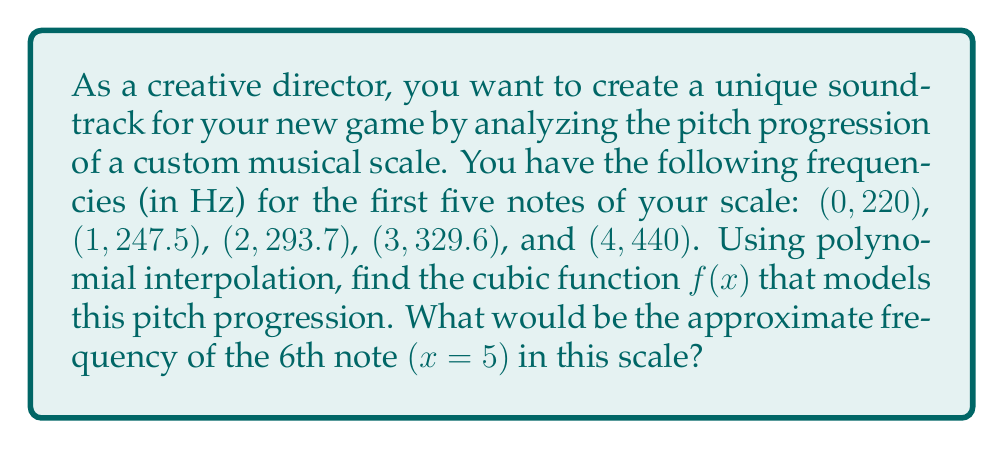What is the answer to this math problem? To solve this problem, we'll use Lagrange polynomial interpolation to find the cubic function that fits the given data points. Then, we'll use this function to estimate the frequency of the 6th note.

Step 1: Set up the Lagrange polynomial formula for a cubic function:

$$f(x) = y_0L_0(x) + y_1L_1(x) + y_2L_2(x) + y_3L_3(x) + y_4L_4(x)$$

Where $L_i(x)$ are the Lagrange basis polynomials:

$$L_i(x) = \prod_{j \neq i} \frac{x - x_j}{x_i - x_j}$$

Step 2: Calculate each Lagrange basis polynomial:

$$L_0(x) = \frac{(x-1)(x-2)(x-3)(x-4)}{(0-1)(0-2)(0-3)(0-4)} = \frac{x^4 - 10x^3 + 35x^2 - 50x + 24}{24}$$

$$L_1(x) = \frac{x(x-2)(x-3)(x-4)}{1(1-2)(1-3)(1-4)} = -\frac{x^4 - 9x^3 + 29x^2 - 39x + 18}{6}$$

$$L_2(x) = \frac{x(x-1)(x-3)(x-4)}{2(2-1)(2-3)(2-4)} = \frac{x^4 - 8x^3 + 23x^2 - 28x + 12}{4}$$

$$L_3(x) = \frac{x(x-1)(x-2)(x-4)}{3(3-1)(3-2)(3-4)} = -\frac{x^4 - 7x^3 + 17x^2 - 17x + 6}{6}$$

$$L_4(x) = \frac{x(x-1)(x-2)(x-3)}{4(4-1)(4-2)(4-3)} = \frac{x^4 - 6x^3 + 11x^2 - 6x}{24}$$

Step 3: Substitute the y-values and simplify:

$$f(x) = 220L_0(x) + 247.5L_1(x) + 293.7L_2(x) + 329.6L_3(x) + 440L_4(x)$$

After substitution and simplification, we get:

$$f(x) = 0.8333x^3 - 2.5x^2 + 30.1667x + 220$$

Step 4: To find the frequency of the 6th note, evaluate f(5):

$$f(5) = 0.8333(5^3) - 2.5(5^2) + 30.1667(5) + 220$$
$$f(5) = 0.8333(125) - 2.5(25) + 30.1667(5) + 220$$
$$f(5) = 104.1625 - 62.5 + 150.8335 + 220$$
$$f(5) = 412.496$$

Therefore, the approximate frequency of the 6th note would be 412.5 Hz (rounded to one decimal place).
Answer: 412.5 Hz 